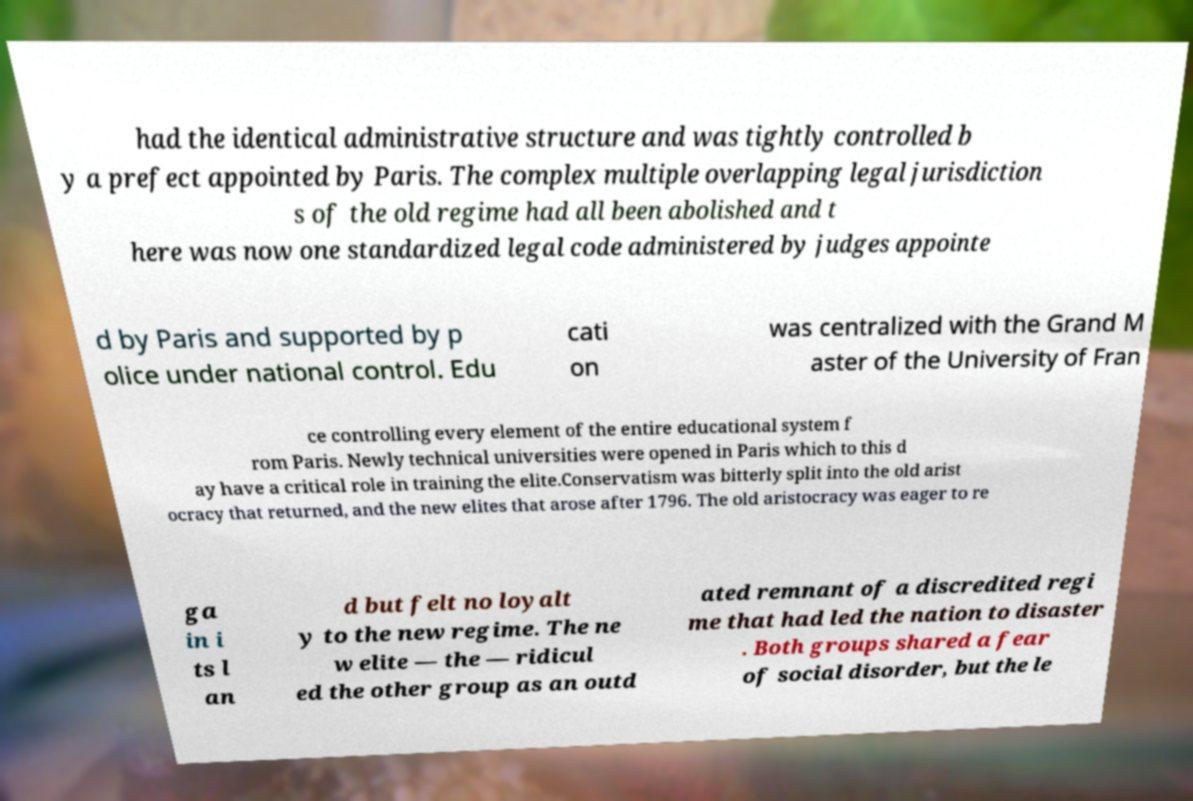There's text embedded in this image that I need extracted. Can you transcribe it verbatim? had the identical administrative structure and was tightly controlled b y a prefect appointed by Paris. The complex multiple overlapping legal jurisdiction s of the old regime had all been abolished and t here was now one standardized legal code administered by judges appointe d by Paris and supported by p olice under national control. Edu cati on was centralized with the Grand M aster of the University of Fran ce controlling every element of the entire educational system f rom Paris. Newly technical universities were opened in Paris which to this d ay have a critical role in training the elite.Conservatism was bitterly split into the old arist ocracy that returned, and the new elites that arose after 1796. The old aristocracy was eager to re ga in i ts l an d but felt no loyalt y to the new regime. The ne w elite — the — ridicul ed the other group as an outd ated remnant of a discredited regi me that had led the nation to disaster . Both groups shared a fear of social disorder, but the le 